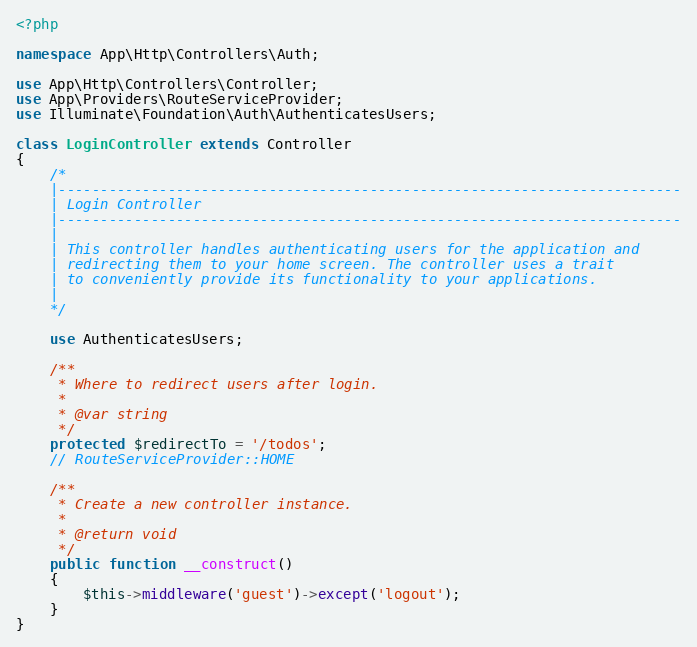<code> <loc_0><loc_0><loc_500><loc_500><_PHP_><?php

namespace App\Http\Controllers\Auth;

use App\Http\Controllers\Controller;
use App\Providers\RouteServiceProvider;
use Illuminate\Foundation\Auth\AuthenticatesUsers;

class LoginController extends Controller
{
    /*
    |--------------------------------------------------------------------------
    | Login Controller
    |--------------------------------------------------------------------------
    |
    | This controller handles authenticating users for the application and
    | redirecting them to your home screen. The controller uses a trait
    | to conveniently provide its functionality to your applications.
    |
    */

    use AuthenticatesUsers;

    /**
     * Where to redirect users after login.
     *
     * @var string
     */
    protected $redirectTo = '/todos';
    // RouteServiceProvider::HOME

    /**
     * Create a new controller instance.
     *
     * @return void
     */
    public function __construct()
    {
        $this->middleware('guest')->except('logout');
    }
}
</code> 